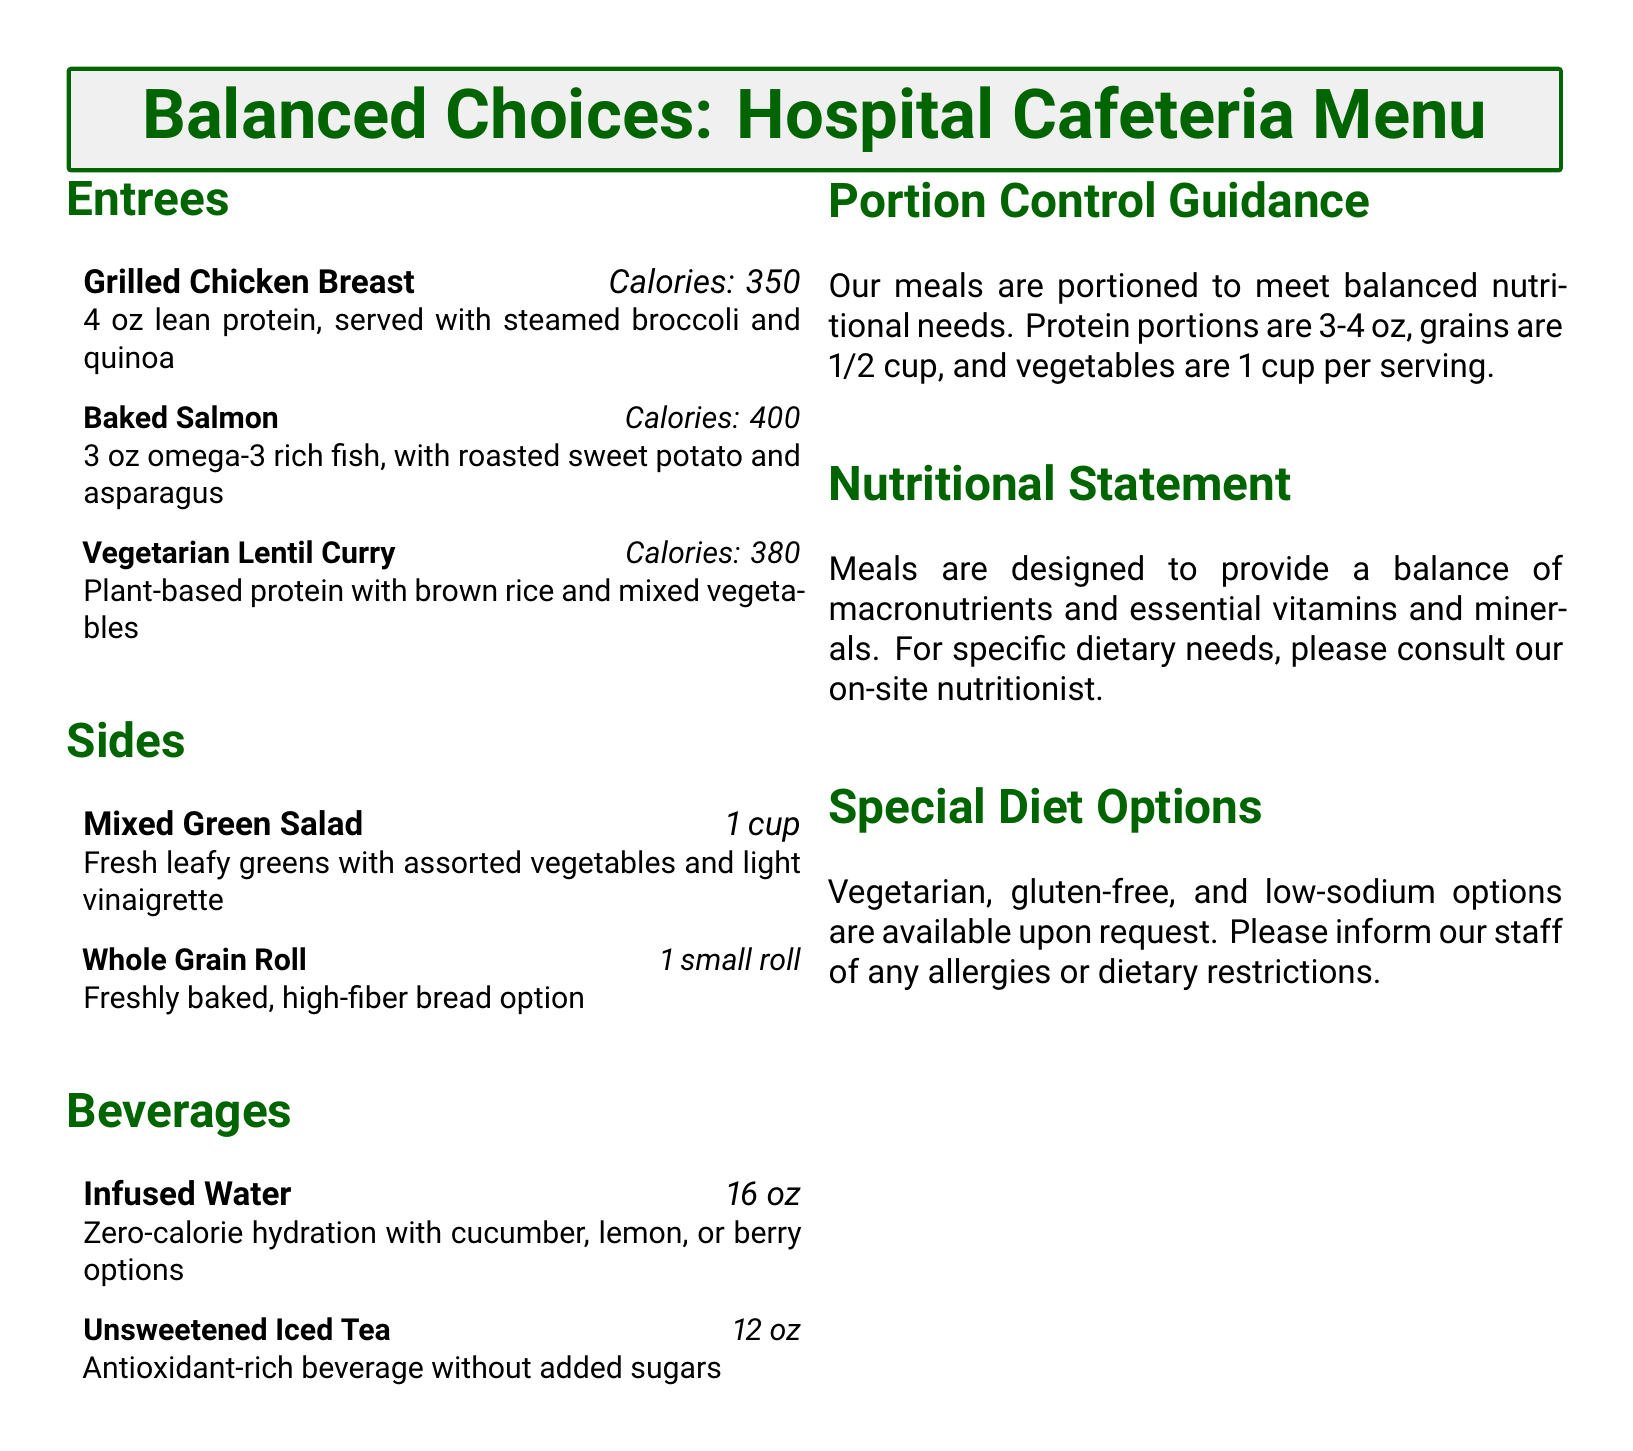what is the calorie content of Grilled Chicken Breast? The calorie content is specified in the entree section of the menu.
Answer: 350 how many ounces of Baked Salmon are served? The serving size is indicated in the entree description for Baked Salmon.
Answer: 3 oz what type of beverage is unsweetened iced tea? The beverage type is categorized under the beverages section of the menu.
Answer: Antioxidant-rich beverage without added sugars what is the portion size for vegetables per serving? The portion control guidance section outlines the serving size for vegetables specifically.
Answer: 1 cup are gluten-free options available? Special diet options are mentioned within the menu regarding dietary accommodations.
Answer: Yes what is the total calorie content of Vegetarian Lentil Curry? The calorie content is mentioned directly in the description of the Vegetarian Lentil Curry in the menu.
Answer: 380 how many ounces of protein are suggested per serving? The recommended protein serving size is listed in the portion control guidance section.
Answer: 3-4 oz what is served alongside Grilled Chicken Breast? The sides accompanying the Grilled Chicken Breast are detailed in the entree description.
Answer: Steamed broccoli and quinoa what nutrient balance does the menu aim to provide? The menu's aim is stated in the nutritional statement section.
Answer: Balance of macronutrients and essential vitamins and minerals 